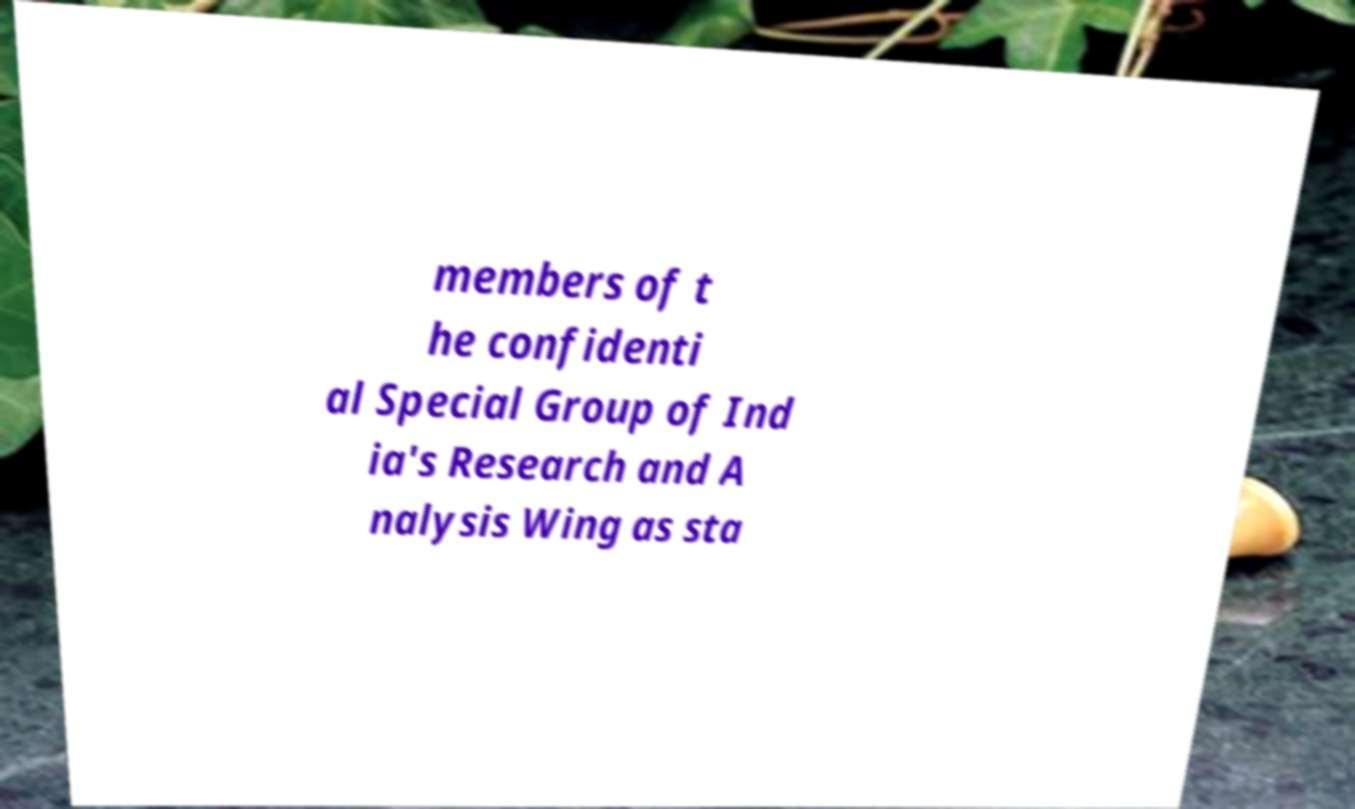Please identify and transcribe the text found in this image. members of t he confidenti al Special Group of Ind ia's Research and A nalysis Wing as sta 